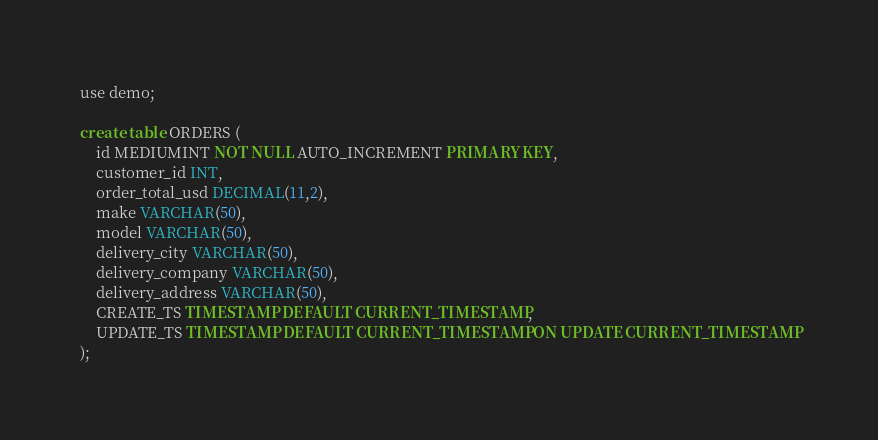Convert code to text. <code><loc_0><loc_0><loc_500><loc_500><_SQL_>use demo;

create table ORDERS (
	id MEDIUMINT NOT NULL AUTO_INCREMENT PRIMARY KEY,
	customer_id INT,
	order_total_usd DECIMAL(11,2),
	make VARCHAR(50),
	model VARCHAR(50),
	delivery_city VARCHAR(50),
	delivery_company VARCHAR(50),
	delivery_address VARCHAR(50),
	CREATE_TS TIMESTAMP DEFAULT CURRENT_TIMESTAMP,
	UPDATE_TS TIMESTAMP DEFAULT CURRENT_TIMESTAMP ON UPDATE CURRENT_TIMESTAMP
);
</code> 